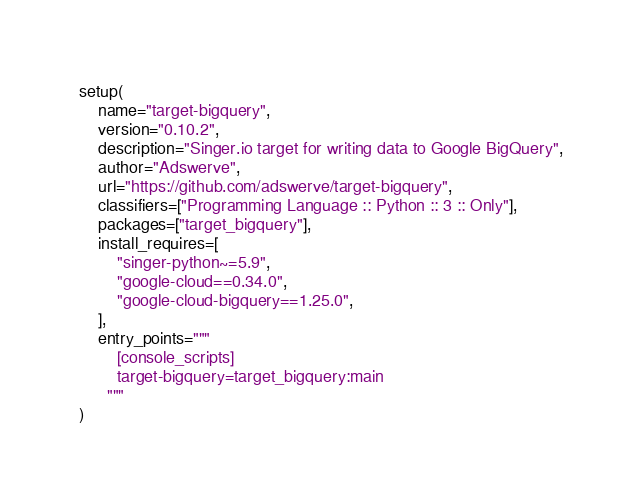<code> <loc_0><loc_0><loc_500><loc_500><_Python_>
setup(
    name="target-bigquery",
    version="0.10.2",
    description="Singer.io target for writing data to Google BigQuery",
    author="Adswerve",
    url="https://github.com/adswerve/target-bigquery",
    classifiers=["Programming Language :: Python :: 3 :: Only"],
    packages=["target_bigquery"],
    install_requires=[
        "singer-python~=5.9",
        "google-cloud==0.34.0",
        "google-cloud-bigquery==1.25.0",
    ],
    entry_points="""
        [console_scripts]
        target-bigquery=target_bigquery:main
      """
)
</code> 